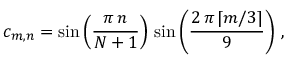Convert formula to latex. <formula><loc_0><loc_0><loc_500><loc_500>c _ { m , n } = \sin \left ( \frac { \pi \, n } { N + 1 } \right ) \, \sin \left ( \frac { 2 \, \pi \, \lceil { m / 3 } \rceil } { 9 } \right ) \, ,</formula> 